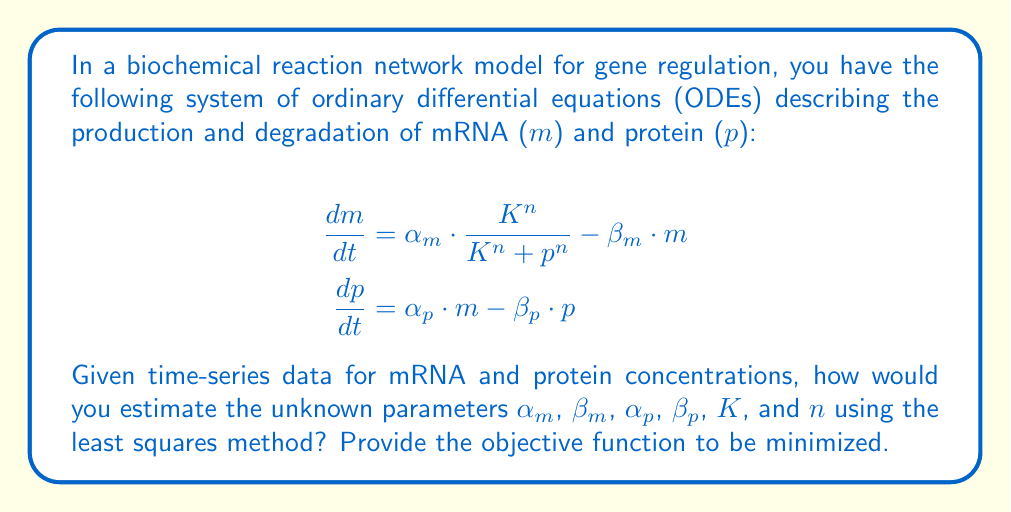Help me with this question. To estimate the unknown parameters in this biochemical reaction network model using the least squares method, we need to follow these steps:

1. Define the model predictions:
   Let $m_i(t)$ and $p_i(t)$ be the model predictions for mRNA and protein concentrations at time $t$, respectively, given a set of parameters $\theta = (\alpha_m, \beta_m, \alpha_p, \beta_p, K, n)$.

2. Collect experimental data:
   Let $m_i^{exp}(t_j)$ and $p_i^{exp}(t_j)$ be the experimentally measured mRNA and protein concentrations at time points $t_j$, where $i = 1, 2, ..., N$ (number of experiments) and $j = 1, 2, ..., M$ (number of time points).

3. Define the residuals:
   The residuals are the differences between the model predictions and the experimental data:
   $$r_m(t_j) = m_i(t_j) - m_i^{exp}(t_j)$$
   $$r_p(t_j) = p_i(t_j) - p_i^{exp}(t_j)$$

4. Formulate the objective function:
   The objective function to be minimized is the sum of squared residuals:
   $$S(\theta) = \sum_{i=1}^N \sum_{j=1}^M \left[w_m \cdot r_m(t_j)^2 + w_p \cdot r_p(t_j)^2\right]$$
   where $w_m$ and $w_p$ are weighting factors for mRNA and protein residuals, respectively.

5. Minimize the objective function:
   Find the set of parameters $\theta^*$ that minimizes $S(\theta)$:
   $$\theta^* = \arg\min_\theta S(\theta)$$

To solve this optimization problem in a bioinformatics workflow using WDL, you would typically:

1. Implement a numerical ODE solver to compute $m_i(t)$ and $p_i(t)$ given a set of parameters.
2. Define the objective function $S(\theta)$ in your code.
3. Use an optimization algorithm (e.g., Levenberg-Marquardt, Nelder-Mead, or gradient descent) to find the optimal parameters $\theta^*$.
4. Implement this process in a WDL workflow, possibly using existing tools or custom scripts for ODE solving and optimization.

The least squares method provides a way to estimate the unknown parameters by minimizing the discrepancy between the model predictions and the experimental data.
Answer: Minimize: $S(\theta) = \sum_{i=1}^N \sum_{j=1}^M \left[w_m \cdot (m_i(t_j) - m_i^{exp}(t_j))^2 + w_p \cdot (p_i(t_j) - p_i^{exp}(t_j))^2\right]$ 